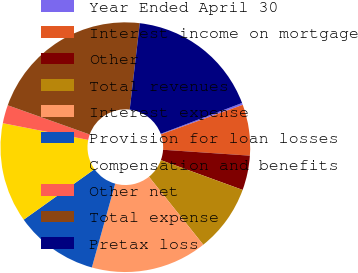Convert chart. <chart><loc_0><loc_0><loc_500><loc_500><pie_chart><fcel>Year Ended April 30<fcel>Interest income on mortgage<fcel>Other<fcel>Total revenues<fcel>Interest expense<fcel>Provision for loan losses<fcel>Compensation and benefits<fcel>Other net<fcel>Total expense<fcel>Pretax loss<nl><fcel>0.25%<fcel>6.59%<fcel>4.48%<fcel>8.71%<fcel>15.05%<fcel>10.82%<fcel>12.94%<fcel>2.37%<fcel>21.4%<fcel>17.39%<nl></chart> 